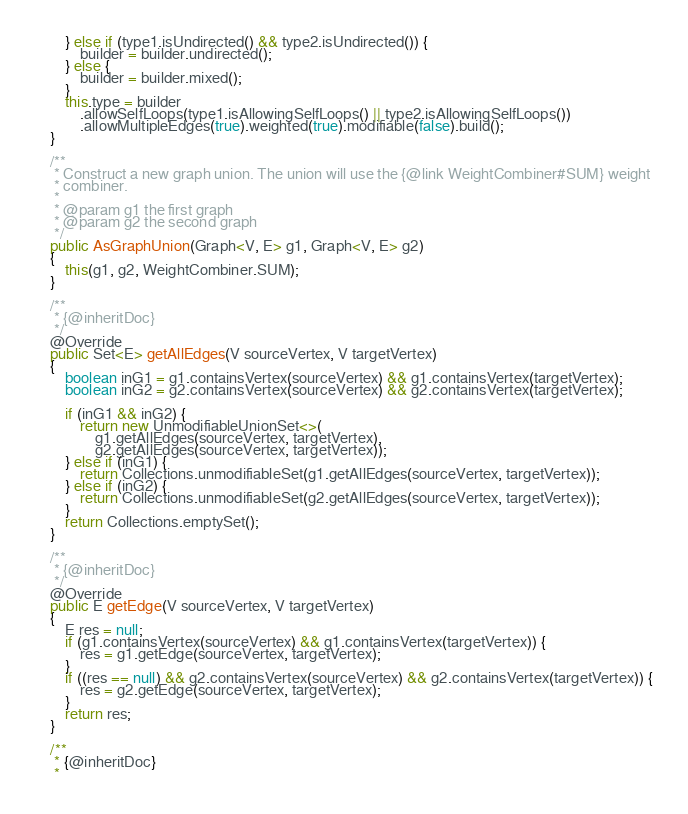<code> <loc_0><loc_0><loc_500><loc_500><_Java_>        } else if (type1.isUndirected() && type2.isUndirected()) {
            builder = builder.undirected();
        } else {
            builder = builder.mixed();
        }
        this.type = builder
            .allowSelfLoops(type1.isAllowingSelfLoops() || type2.isAllowingSelfLoops())
            .allowMultipleEdges(true).weighted(true).modifiable(false).build();
    }

    /**
     * Construct a new graph union. The union will use the {@link WeightCombiner#SUM} weight
     * combiner.
     * 
     * @param g1 the first graph
     * @param g2 the second graph
     */
    public AsGraphUnion(Graph<V, E> g1, Graph<V, E> g2)
    {
        this(g1, g2, WeightCombiner.SUM);
    }

    /**
     * {@inheritDoc}
     */
    @Override
    public Set<E> getAllEdges(V sourceVertex, V targetVertex)
    {
        boolean inG1 = g1.containsVertex(sourceVertex) && g1.containsVertex(targetVertex);
        boolean inG2 = g2.containsVertex(sourceVertex) && g2.containsVertex(targetVertex);

        if (inG1 && inG2) {
            return new UnmodifiableUnionSet<>(
                g1.getAllEdges(sourceVertex, targetVertex),
                g2.getAllEdges(sourceVertex, targetVertex));
        } else if (inG1) {
            return Collections.unmodifiableSet(g1.getAllEdges(sourceVertex, targetVertex));
        } else if (inG2) {
            return Collections.unmodifiableSet(g2.getAllEdges(sourceVertex, targetVertex));
        }
        return Collections.emptySet();
    }

    /**
     * {@inheritDoc}
     */
    @Override
    public E getEdge(V sourceVertex, V targetVertex)
    {
        E res = null;
        if (g1.containsVertex(sourceVertex) && g1.containsVertex(targetVertex)) {
            res = g1.getEdge(sourceVertex, targetVertex);
        }
        if ((res == null) && g2.containsVertex(sourceVertex) && g2.containsVertex(targetVertex)) {
            res = g2.getEdge(sourceVertex, targetVertex);
        }
        return res;
    }

    /**
     * {@inheritDoc}
     * </code> 